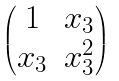<formula> <loc_0><loc_0><loc_500><loc_500>\begin{pmatrix} 1 & x _ { 3 } \\ x _ { 3 } & x _ { 3 } ^ { 2 } \end{pmatrix}</formula> 